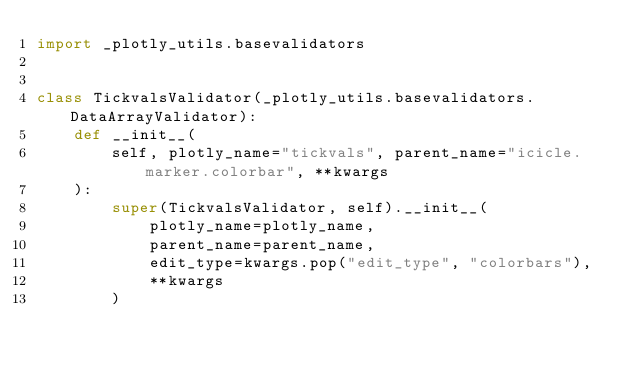Convert code to text. <code><loc_0><loc_0><loc_500><loc_500><_Python_>import _plotly_utils.basevalidators


class TickvalsValidator(_plotly_utils.basevalidators.DataArrayValidator):
    def __init__(
        self, plotly_name="tickvals", parent_name="icicle.marker.colorbar", **kwargs
    ):
        super(TickvalsValidator, self).__init__(
            plotly_name=plotly_name,
            parent_name=parent_name,
            edit_type=kwargs.pop("edit_type", "colorbars"),
            **kwargs
        )
</code> 